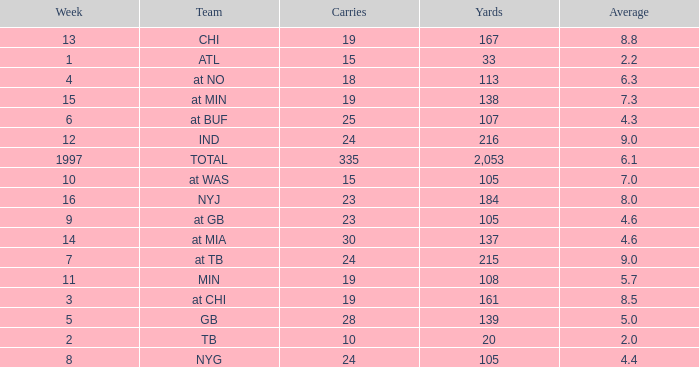Which Average has Yards larger than 167, and a Team of at tb, and a Week larger than 7? None. 